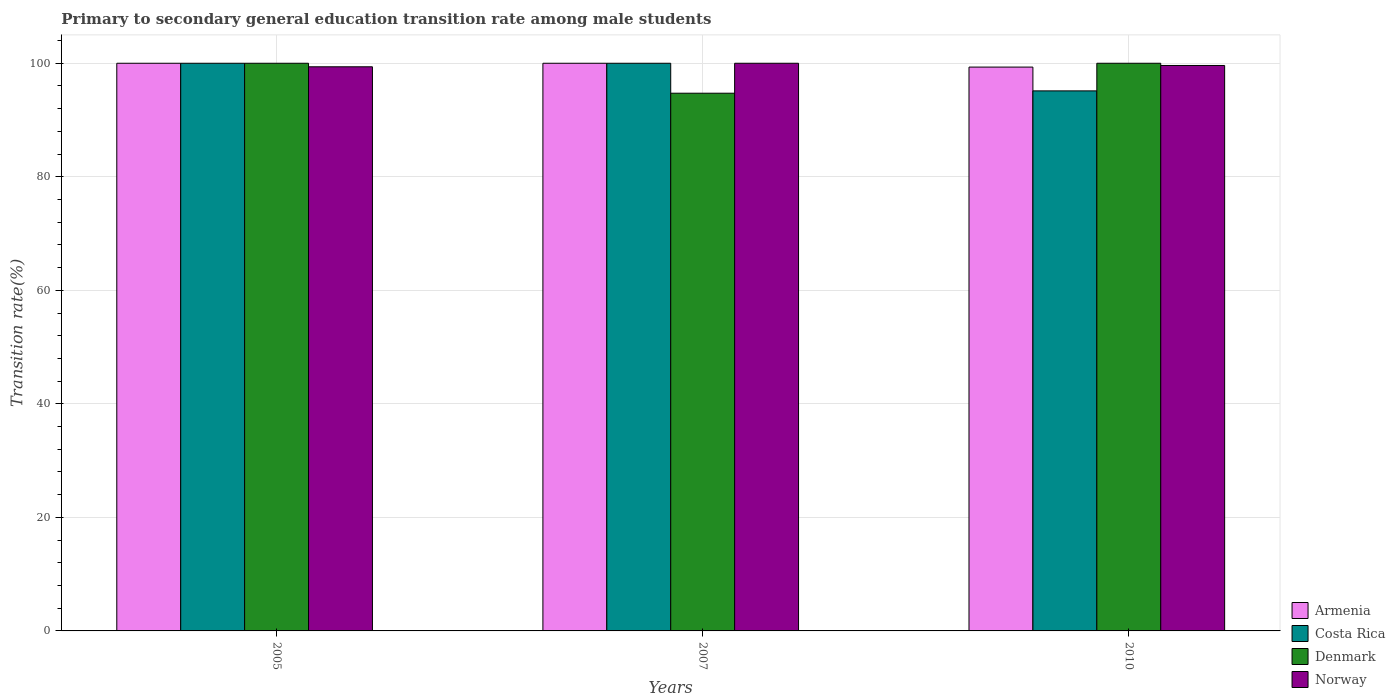How many different coloured bars are there?
Offer a very short reply. 4. Are the number of bars per tick equal to the number of legend labels?
Provide a short and direct response. Yes. Are the number of bars on each tick of the X-axis equal?
Offer a very short reply. Yes. What is the transition rate in Norway in 2005?
Offer a very short reply. 99.38. Across all years, what is the minimum transition rate in Denmark?
Offer a terse response. 94.72. In which year was the transition rate in Armenia maximum?
Ensure brevity in your answer.  2005. In which year was the transition rate in Armenia minimum?
Your answer should be compact. 2010. What is the total transition rate in Denmark in the graph?
Keep it short and to the point. 294.72. What is the difference between the transition rate in Denmark in 2005 and that in 2010?
Your answer should be very brief. 0. What is the difference between the transition rate in Armenia in 2010 and the transition rate in Denmark in 2005?
Provide a short and direct response. -0.67. What is the average transition rate in Denmark per year?
Provide a short and direct response. 98.24. In the year 2010, what is the difference between the transition rate in Costa Rica and transition rate in Armenia?
Keep it short and to the point. -4.19. What is the ratio of the transition rate in Denmark in 2007 to that in 2010?
Provide a succinct answer. 0.95. Is the transition rate in Armenia in 2007 less than that in 2010?
Make the answer very short. No. What is the difference between the highest and the lowest transition rate in Costa Rica?
Make the answer very short. 4.87. In how many years, is the transition rate in Armenia greater than the average transition rate in Armenia taken over all years?
Keep it short and to the point. 2. Is it the case that in every year, the sum of the transition rate in Norway and transition rate in Armenia is greater than the sum of transition rate in Denmark and transition rate in Costa Rica?
Make the answer very short. No. What does the 1st bar from the left in 2010 represents?
Keep it short and to the point. Armenia. What does the 4th bar from the right in 2010 represents?
Make the answer very short. Armenia. Is it the case that in every year, the sum of the transition rate in Denmark and transition rate in Costa Rica is greater than the transition rate in Norway?
Your answer should be compact. Yes. Are all the bars in the graph horizontal?
Offer a very short reply. No. Are the values on the major ticks of Y-axis written in scientific E-notation?
Your answer should be very brief. No. Does the graph contain grids?
Your response must be concise. Yes. Where does the legend appear in the graph?
Your response must be concise. Bottom right. How are the legend labels stacked?
Provide a succinct answer. Vertical. What is the title of the graph?
Your response must be concise. Primary to secondary general education transition rate among male students. What is the label or title of the X-axis?
Your answer should be compact. Years. What is the label or title of the Y-axis?
Offer a very short reply. Transition rate(%). What is the Transition rate(%) in Armenia in 2005?
Ensure brevity in your answer.  100. What is the Transition rate(%) of Costa Rica in 2005?
Your response must be concise. 100. What is the Transition rate(%) in Norway in 2005?
Ensure brevity in your answer.  99.38. What is the Transition rate(%) in Armenia in 2007?
Keep it short and to the point. 100. What is the Transition rate(%) of Costa Rica in 2007?
Your response must be concise. 100. What is the Transition rate(%) of Denmark in 2007?
Your answer should be compact. 94.72. What is the Transition rate(%) in Armenia in 2010?
Provide a short and direct response. 99.33. What is the Transition rate(%) of Costa Rica in 2010?
Keep it short and to the point. 95.13. What is the Transition rate(%) of Denmark in 2010?
Your answer should be compact. 100. What is the Transition rate(%) in Norway in 2010?
Offer a very short reply. 99.61. Across all years, what is the maximum Transition rate(%) in Costa Rica?
Offer a terse response. 100. Across all years, what is the maximum Transition rate(%) of Norway?
Keep it short and to the point. 100. Across all years, what is the minimum Transition rate(%) in Armenia?
Offer a terse response. 99.33. Across all years, what is the minimum Transition rate(%) of Costa Rica?
Offer a terse response. 95.13. Across all years, what is the minimum Transition rate(%) of Denmark?
Make the answer very short. 94.72. Across all years, what is the minimum Transition rate(%) of Norway?
Provide a short and direct response. 99.38. What is the total Transition rate(%) of Armenia in the graph?
Make the answer very short. 299.33. What is the total Transition rate(%) of Costa Rica in the graph?
Ensure brevity in your answer.  295.13. What is the total Transition rate(%) of Denmark in the graph?
Your answer should be very brief. 294.72. What is the total Transition rate(%) of Norway in the graph?
Give a very brief answer. 298.99. What is the difference between the Transition rate(%) of Denmark in 2005 and that in 2007?
Your answer should be compact. 5.28. What is the difference between the Transition rate(%) in Norway in 2005 and that in 2007?
Ensure brevity in your answer.  -0.62. What is the difference between the Transition rate(%) in Armenia in 2005 and that in 2010?
Provide a succinct answer. 0.67. What is the difference between the Transition rate(%) in Costa Rica in 2005 and that in 2010?
Your answer should be very brief. 4.87. What is the difference between the Transition rate(%) of Norway in 2005 and that in 2010?
Offer a very short reply. -0.23. What is the difference between the Transition rate(%) in Armenia in 2007 and that in 2010?
Keep it short and to the point. 0.67. What is the difference between the Transition rate(%) in Costa Rica in 2007 and that in 2010?
Offer a very short reply. 4.87. What is the difference between the Transition rate(%) in Denmark in 2007 and that in 2010?
Provide a succinct answer. -5.28. What is the difference between the Transition rate(%) of Norway in 2007 and that in 2010?
Make the answer very short. 0.39. What is the difference between the Transition rate(%) in Armenia in 2005 and the Transition rate(%) in Costa Rica in 2007?
Your answer should be compact. 0. What is the difference between the Transition rate(%) in Armenia in 2005 and the Transition rate(%) in Denmark in 2007?
Your answer should be very brief. 5.28. What is the difference between the Transition rate(%) of Costa Rica in 2005 and the Transition rate(%) of Denmark in 2007?
Ensure brevity in your answer.  5.28. What is the difference between the Transition rate(%) of Costa Rica in 2005 and the Transition rate(%) of Norway in 2007?
Make the answer very short. 0. What is the difference between the Transition rate(%) in Armenia in 2005 and the Transition rate(%) in Costa Rica in 2010?
Give a very brief answer. 4.87. What is the difference between the Transition rate(%) in Armenia in 2005 and the Transition rate(%) in Denmark in 2010?
Provide a short and direct response. 0. What is the difference between the Transition rate(%) of Armenia in 2005 and the Transition rate(%) of Norway in 2010?
Make the answer very short. 0.39. What is the difference between the Transition rate(%) in Costa Rica in 2005 and the Transition rate(%) in Norway in 2010?
Keep it short and to the point. 0.39. What is the difference between the Transition rate(%) of Denmark in 2005 and the Transition rate(%) of Norway in 2010?
Provide a short and direct response. 0.39. What is the difference between the Transition rate(%) of Armenia in 2007 and the Transition rate(%) of Costa Rica in 2010?
Your response must be concise. 4.87. What is the difference between the Transition rate(%) of Armenia in 2007 and the Transition rate(%) of Denmark in 2010?
Make the answer very short. 0. What is the difference between the Transition rate(%) in Armenia in 2007 and the Transition rate(%) in Norway in 2010?
Your answer should be compact. 0.39. What is the difference between the Transition rate(%) in Costa Rica in 2007 and the Transition rate(%) in Denmark in 2010?
Your answer should be very brief. 0. What is the difference between the Transition rate(%) of Costa Rica in 2007 and the Transition rate(%) of Norway in 2010?
Provide a short and direct response. 0.39. What is the difference between the Transition rate(%) in Denmark in 2007 and the Transition rate(%) in Norway in 2010?
Make the answer very short. -4.89. What is the average Transition rate(%) of Armenia per year?
Offer a terse response. 99.78. What is the average Transition rate(%) of Costa Rica per year?
Provide a succinct answer. 98.38. What is the average Transition rate(%) in Denmark per year?
Your answer should be compact. 98.24. What is the average Transition rate(%) of Norway per year?
Provide a succinct answer. 99.66. In the year 2005, what is the difference between the Transition rate(%) in Armenia and Transition rate(%) in Costa Rica?
Make the answer very short. 0. In the year 2005, what is the difference between the Transition rate(%) of Armenia and Transition rate(%) of Denmark?
Make the answer very short. 0. In the year 2005, what is the difference between the Transition rate(%) of Armenia and Transition rate(%) of Norway?
Ensure brevity in your answer.  0.62. In the year 2005, what is the difference between the Transition rate(%) in Costa Rica and Transition rate(%) in Norway?
Offer a terse response. 0.62. In the year 2005, what is the difference between the Transition rate(%) in Denmark and Transition rate(%) in Norway?
Your response must be concise. 0.62. In the year 2007, what is the difference between the Transition rate(%) of Armenia and Transition rate(%) of Costa Rica?
Offer a very short reply. 0. In the year 2007, what is the difference between the Transition rate(%) in Armenia and Transition rate(%) in Denmark?
Offer a terse response. 5.28. In the year 2007, what is the difference between the Transition rate(%) of Armenia and Transition rate(%) of Norway?
Your answer should be compact. 0. In the year 2007, what is the difference between the Transition rate(%) in Costa Rica and Transition rate(%) in Denmark?
Your answer should be very brief. 5.28. In the year 2007, what is the difference between the Transition rate(%) in Denmark and Transition rate(%) in Norway?
Give a very brief answer. -5.28. In the year 2010, what is the difference between the Transition rate(%) in Armenia and Transition rate(%) in Costa Rica?
Give a very brief answer. 4.19. In the year 2010, what is the difference between the Transition rate(%) of Armenia and Transition rate(%) of Denmark?
Provide a succinct answer. -0.67. In the year 2010, what is the difference between the Transition rate(%) of Armenia and Transition rate(%) of Norway?
Provide a short and direct response. -0.28. In the year 2010, what is the difference between the Transition rate(%) of Costa Rica and Transition rate(%) of Denmark?
Keep it short and to the point. -4.87. In the year 2010, what is the difference between the Transition rate(%) of Costa Rica and Transition rate(%) of Norway?
Offer a very short reply. -4.48. In the year 2010, what is the difference between the Transition rate(%) of Denmark and Transition rate(%) of Norway?
Ensure brevity in your answer.  0.39. What is the ratio of the Transition rate(%) in Armenia in 2005 to that in 2007?
Offer a terse response. 1. What is the ratio of the Transition rate(%) in Denmark in 2005 to that in 2007?
Provide a succinct answer. 1.06. What is the ratio of the Transition rate(%) in Norway in 2005 to that in 2007?
Your answer should be very brief. 0.99. What is the ratio of the Transition rate(%) of Armenia in 2005 to that in 2010?
Your response must be concise. 1.01. What is the ratio of the Transition rate(%) of Costa Rica in 2005 to that in 2010?
Make the answer very short. 1.05. What is the ratio of the Transition rate(%) in Norway in 2005 to that in 2010?
Your answer should be very brief. 1. What is the ratio of the Transition rate(%) of Armenia in 2007 to that in 2010?
Provide a short and direct response. 1.01. What is the ratio of the Transition rate(%) in Costa Rica in 2007 to that in 2010?
Your response must be concise. 1.05. What is the ratio of the Transition rate(%) of Denmark in 2007 to that in 2010?
Provide a short and direct response. 0.95. What is the difference between the highest and the second highest Transition rate(%) in Armenia?
Your response must be concise. 0. What is the difference between the highest and the second highest Transition rate(%) in Denmark?
Ensure brevity in your answer.  0. What is the difference between the highest and the second highest Transition rate(%) of Norway?
Give a very brief answer. 0.39. What is the difference between the highest and the lowest Transition rate(%) of Armenia?
Your response must be concise. 0.67. What is the difference between the highest and the lowest Transition rate(%) of Costa Rica?
Provide a succinct answer. 4.87. What is the difference between the highest and the lowest Transition rate(%) of Denmark?
Your response must be concise. 5.28. What is the difference between the highest and the lowest Transition rate(%) of Norway?
Give a very brief answer. 0.62. 